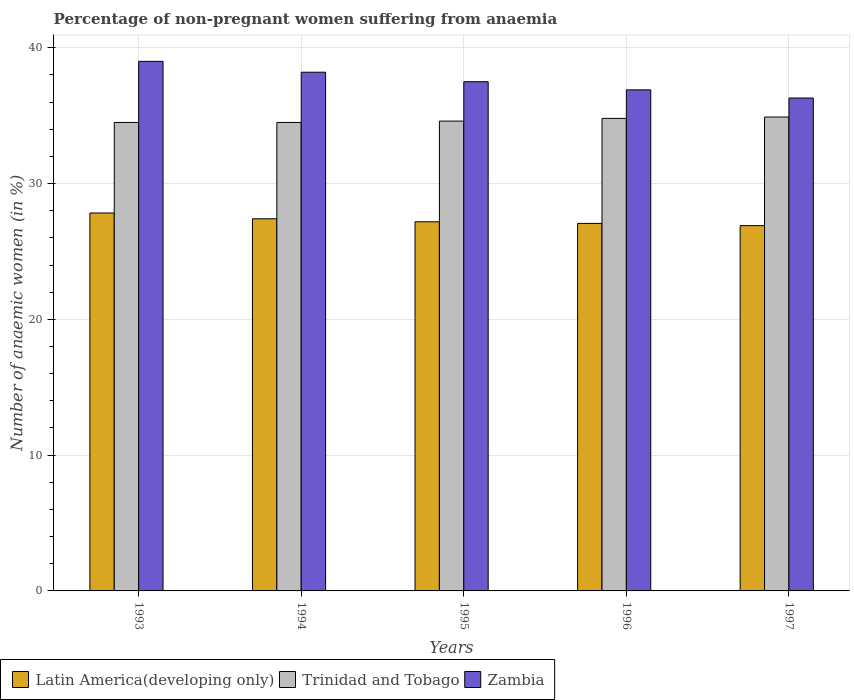How many groups of bars are there?
Provide a short and direct response. 5. Are the number of bars on each tick of the X-axis equal?
Offer a terse response. Yes. How many bars are there on the 3rd tick from the left?
Give a very brief answer. 3. How many bars are there on the 1st tick from the right?
Give a very brief answer. 3. What is the label of the 1st group of bars from the left?
Your answer should be very brief. 1993. In how many cases, is the number of bars for a given year not equal to the number of legend labels?
Your response must be concise. 0. What is the percentage of non-pregnant women suffering from anaemia in Trinidad and Tobago in 1995?
Your answer should be compact. 34.6. Across all years, what is the maximum percentage of non-pregnant women suffering from anaemia in Trinidad and Tobago?
Keep it short and to the point. 34.9. Across all years, what is the minimum percentage of non-pregnant women suffering from anaemia in Trinidad and Tobago?
Offer a terse response. 34.5. In which year was the percentage of non-pregnant women suffering from anaemia in Latin America(developing only) maximum?
Your answer should be very brief. 1993. In which year was the percentage of non-pregnant women suffering from anaemia in Zambia minimum?
Give a very brief answer. 1997. What is the total percentage of non-pregnant women suffering from anaemia in Latin America(developing only) in the graph?
Give a very brief answer. 136.39. What is the difference between the percentage of non-pregnant women suffering from anaemia in Trinidad and Tobago in 1995 and that in 1997?
Keep it short and to the point. -0.3. What is the difference between the percentage of non-pregnant women suffering from anaemia in Latin America(developing only) in 1993 and the percentage of non-pregnant women suffering from anaemia in Trinidad and Tobago in 1996?
Your answer should be very brief. -6.97. What is the average percentage of non-pregnant women suffering from anaemia in Trinidad and Tobago per year?
Provide a succinct answer. 34.66. In the year 1994, what is the difference between the percentage of non-pregnant women suffering from anaemia in Trinidad and Tobago and percentage of non-pregnant women suffering from anaemia in Zambia?
Give a very brief answer. -3.7. In how many years, is the percentage of non-pregnant women suffering from anaemia in Trinidad and Tobago greater than 18 %?
Keep it short and to the point. 5. What is the ratio of the percentage of non-pregnant women suffering from anaemia in Zambia in 1993 to that in 1994?
Make the answer very short. 1.02. Is the percentage of non-pregnant women suffering from anaemia in Zambia in 1994 less than that in 1997?
Make the answer very short. No. Is the difference between the percentage of non-pregnant women suffering from anaemia in Trinidad and Tobago in 1996 and 1997 greater than the difference between the percentage of non-pregnant women suffering from anaemia in Zambia in 1996 and 1997?
Provide a succinct answer. No. What is the difference between the highest and the second highest percentage of non-pregnant women suffering from anaemia in Trinidad and Tobago?
Offer a terse response. 0.1. What is the difference between the highest and the lowest percentage of non-pregnant women suffering from anaemia in Trinidad and Tobago?
Make the answer very short. 0.4. Is the sum of the percentage of non-pregnant women suffering from anaemia in Zambia in 1994 and 1996 greater than the maximum percentage of non-pregnant women suffering from anaemia in Trinidad and Tobago across all years?
Your response must be concise. Yes. What does the 3rd bar from the left in 1997 represents?
Offer a terse response. Zambia. What does the 1st bar from the right in 1993 represents?
Keep it short and to the point. Zambia. How many bars are there?
Provide a short and direct response. 15. How many years are there in the graph?
Your answer should be very brief. 5. Does the graph contain grids?
Make the answer very short. Yes. Where does the legend appear in the graph?
Offer a terse response. Bottom left. How many legend labels are there?
Keep it short and to the point. 3. What is the title of the graph?
Offer a very short reply. Percentage of non-pregnant women suffering from anaemia. Does "Burundi" appear as one of the legend labels in the graph?
Give a very brief answer. No. What is the label or title of the Y-axis?
Make the answer very short. Number of anaemic women (in %). What is the Number of anaemic women (in %) of Latin America(developing only) in 1993?
Keep it short and to the point. 27.83. What is the Number of anaemic women (in %) of Trinidad and Tobago in 1993?
Your answer should be very brief. 34.5. What is the Number of anaemic women (in %) of Latin America(developing only) in 1994?
Offer a very short reply. 27.41. What is the Number of anaemic women (in %) of Trinidad and Tobago in 1994?
Offer a very short reply. 34.5. What is the Number of anaemic women (in %) in Zambia in 1994?
Offer a terse response. 38.2. What is the Number of anaemic women (in %) in Latin America(developing only) in 1995?
Your answer should be very brief. 27.19. What is the Number of anaemic women (in %) of Trinidad and Tobago in 1995?
Offer a terse response. 34.6. What is the Number of anaemic women (in %) of Zambia in 1995?
Your answer should be compact. 37.5. What is the Number of anaemic women (in %) in Latin America(developing only) in 1996?
Provide a short and direct response. 27.07. What is the Number of anaemic women (in %) in Trinidad and Tobago in 1996?
Your response must be concise. 34.8. What is the Number of anaemic women (in %) in Zambia in 1996?
Ensure brevity in your answer.  36.9. What is the Number of anaemic women (in %) of Latin America(developing only) in 1997?
Keep it short and to the point. 26.9. What is the Number of anaemic women (in %) in Trinidad and Tobago in 1997?
Offer a terse response. 34.9. What is the Number of anaemic women (in %) in Zambia in 1997?
Your response must be concise. 36.3. Across all years, what is the maximum Number of anaemic women (in %) in Latin America(developing only)?
Your answer should be very brief. 27.83. Across all years, what is the maximum Number of anaemic women (in %) of Trinidad and Tobago?
Your answer should be very brief. 34.9. Across all years, what is the minimum Number of anaemic women (in %) in Latin America(developing only)?
Provide a short and direct response. 26.9. Across all years, what is the minimum Number of anaemic women (in %) of Trinidad and Tobago?
Provide a succinct answer. 34.5. Across all years, what is the minimum Number of anaemic women (in %) in Zambia?
Offer a very short reply. 36.3. What is the total Number of anaemic women (in %) of Latin America(developing only) in the graph?
Offer a very short reply. 136.39. What is the total Number of anaemic women (in %) of Trinidad and Tobago in the graph?
Offer a terse response. 173.3. What is the total Number of anaemic women (in %) in Zambia in the graph?
Give a very brief answer. 187.9. What is the difference between the Number of anaemic women (in %) of Latin America(developing only) in 1993 and that in 1994?
Provide a succinct answer. 0.43. What is the difference between the Number of anaemic women (in %) in Latin America(developing only) in 1993 and that in 1995?
Keep it short and to the point. 0.65. What is the difference between the Number of anaemic women (in %) of Trinidad and Tobago in 1993 and that in 1995?
Provide a short and direct response. -0.1. What is the difference between the Number of anaemic women (in %) in Latin America(developing only) in 1993 and that in 1996?
Offer a very short reply. 0.77. What is the difference between the Number of anaemic women (in %) of Trinidad and Tobago in 1993 and that in 1996?
Provide a succinct answer. -0.3. What is the difference between the Number of anaemic women (in %) of Zambia in 1993 and that in 1996?
Your answer should be very brief. 2.1. What is the difference between the Number of anaemic women (in %) of Latin America(developing only) in 1993 and that in 1997?
Provide a short and direct response. 0.93. What is the difference between the Number of anaemic women (in %) of Latin America(developing only) in 1994 and that in 1995?
Offer a very short reply. 0.22. What is the difference between the Number of anaemic women (in %) in Latin America(developing only) in 1994 and that in 1996?
Keep it short and to the point. 0.34. What is the difference between the Number of anaemic women (in %) of Latin America(developing only) in 1994 and that in 1997?
Ensure brevity in your answer.  0.51. What is the difference between the Number of anaemic women (in %) of Trinidad and Tobago in 1994 and that in 1997?
Offer a very short reply. -0.4. What is the difference between the Number of anaemic women (in %) in Zambia in 1994 and that in 1997?
Your answer should be very brief. 1.9. What is the difference between the Number of anaemic women (in %) of Latin America(developing only) in 1995 and that in 1996?
Keep it short and to the point. 0.12. What is the difference between the Number of anaemic women (in %) in Zambia in 1995 and that in 1996?
Provide a short and direct response. 0.6. What is the difference between the Number of anaemic women (in %) of Latin America(developing only) in 1995 and that in 1997?
Ensure brevity in your answer.  0.28. What is the difference between the Number of anaemic women (in %) in Trinidad and Tobago in 1995 and that in 1997?
Your answer should be very brief. -0.3. What is the difference between the Number of anaemic women (in %) in Latin America(developing only) in 1996 and that in 1997?
Offer a terse response. 0.16. What is the difference between the Number of anaemic women (in %) in Latin America(developing only) in 1993 and the Number of anaemic women (in %) in Trinidad and Tobago in 1994?
Offer a very short reply. -6.67. What is the difference between the Number of anaemic women (in %) of Latin America(developing only) in 1993 and the Number of anaemic women (in %) of Zambia in 1994?
Provide a short and direct response. -10.37. What is the difference between the Number of anaemic women (in %) of Latin America(developing only) in 1993 and the Number of anaemic women (in %) of Trinidad and Tobago in 1995?
Your response must be concise. -6.77. What is the difference between the Number of anaemic women (in %) in Latin America(developing only) in 1993 and the Number of anaemic women (in %) in Zambia in 1995?
Provide a short and direct response. -9.67. What is the difference between the Number of anaemic women (in %) in Latin America(developing only) in 1993 and the Number of anaemic women (in %) in Trinidad and Tobago in 1996?
Your answer should be very brief. -6.97. What is the difference between the Number of anaemic women (in %) in Latin America(developing only) in 1993 and the Number of anaemic women (in %) in Zambia in 1996?
Your answer should be very brief. -9.07. What is the difference between the Number of anaemic women (in %) in Latin America(developing only) in 1993 and the Number of anaemic women (in %) in Trinidad and Tobago in 1997?
Keep it short and to the point. -7.07. What is the difference between the Number of anaemic women (in %) of Latin America(developing only) in 1993 and the Number of anaemic women (in %) of Zambia in 1997?
Your answer should be very brief. -8.47. What is the difference between the Number of anaemic women (in %) in Latin America(developing only) in 1994 and the Number of anaemic women (in %) in Trinidad and Tobago in 1995?
Offer a terse response. -7.19. What is the difference between the Number of anaemic women (in %) of Latin America(developing only) in 1994 and the Number of anaemic women (in %) of Zambia in 1995?
Ensure brevity in your answer.  -10.09. What is the difference between the Number of anaemic women (in %) of Latin America(developing only) in 1994 and the Number of anaemic women (in %) of Trinidad and Tobago in 1996?
Ensure brevity in your answer.  -7.39. What is the difference between the Number of anaemic women (in %) of Latin America(developing only) in 1994 and the Number of anaemic women (in %) of Zambia in 1996?
Offer a very short reply. -9.49. What is the difference between the Number of anaemic women (in %) in Trinidad and Tobago in 1994 and the Number of anaemic women (in %) in Zambia in 1996?
Offer a very short reply. -2.4. What is the difference between the Number of anaemic women (in %) in Latin America(developing only) in 1994 and the Number of anaemic women (in %) in Trinidad and Tobago in 1997?
Provide a succinct answer. -7.49. What is the difference between the Number of anaemic women (in %) of Latin America(developing only) in 1994 and the Number of anaemic women (in %) of Zambia in 1997?
Provide a short and direct response. -8.89. What is the difference between the Number of anaemic women (in %) of Trinidad and Tobago in 1994 and the Number of anaemic women (in %) of Zambia in 1997?
Your response must be concise. -1.8. What is the difference between the Number of anaemic women (in %) of Latin America(developing only) in 1995 and the Number of anaemic women (in %) of Trinidad and Tobago in 1996?
Your answer should be compact. -7.61. What is the difference between the Number of anaemic women (in %) of Latin America(developing only) in 1995 and the Number of anaemic women (in %) of Zambia in 1996?
Offer a very short reply. -9.71. What is the difference between the Number of anaemic women (in %) of Latin America(developing only) in 1995 and the Number of anaemic women (in %) of Trinidad and Tobago in 1997?
Your answer should be compact. -7.71. What is the difference between the Number of anaemic women (in %) of Latin America(developing only) in 1995 and the Number of anaemic women (in %) of Zambia in 1997?
Your answer should be compact. -9.11. What is the difference between the Number of anaemic women (in %) of Latin America(developing only) in 1996 and the Number of anaemic women (in %) of Trinidad and Tobago in 1997?
Make the answer very short. -7.83. What is the difference between the Number of anaemic women (in %) in Latin America(developing only) in 1996 and the Number of anaemic women (in %) in Zambia in 1997?
Offer a very short reply. -9.23. What is the difference between the Number of anaemic women (in %) of Trinidad and Tobago in 1996 and the Number of anaemic women (in %) of Zambia in 1997?
Ensure brevity in your answer.  -1.5. What is the average Number of anaemic women (in %) of Latin America(developing only) per year?
Provide a succinct answer. 27.28. What is the average Number of anaemic women (in %) in Trinidad and Tobago per year?
Provide a succinct answer. 34.66. What is the average Number of anaemic women (in %) in Zambia per year?
Your answer should be compact. 37.58. In the year 1993, what is the difference between the Number of anaemic women (in %) of Latin America(developing only) and Number of anaemic women (in %) of Trinidad and Tobago?
Your answer should be very brief. -6.67. In the year 1993, what is the difference between the Number of anaemic women (in %) in Latin America(developing only) and Number of anaemic women (in %) in Zambia?
Give a very brief answer. -11.17. In the year 1994, what is the difference between the Number of anaemic women (in %) of Latin America(developing only) and Number of anaemic women (in %) of Trinidad and Tobago?
Your answer should be compact. -7.09. In the year 1994, what is the difference between the Number of anaemic women (in %) of Latin America(developing only) and Number of anaemic women (in %) of Zambia?
Offer a very short reply. -10.79. In the year 1994, what is the difference between the Number of anaemic women (in %) in Trinidad and Tobago and Number of anaemic women (in %) in Zambia?
Provide a succinct answer. -3.7. In the year 1995, what is the difference between the Number of anaemic women (in %) in Latin America(developing only) and Number of anaemic women (in %) in Trinidad and Tobago?
Your answer should be compact. -7.41. In the year 1995, what is the difference between the Number of anaemic women (in %) in Latin America(developing only) and Number of anaemic women (in %) in Zambia?
Give a very brief answer. -10.31. In the year 1995, what is the difference between the Number of anaemic women (in %) of Trinidad and Tobago and Number of anaemic women (in %) of Zambia?
Your answer should be compact. -2.9. In the year 1996, what is the difference between the Number of anaemic women (in %) of Latin America(developing only) and Number of anaemic women (in %) of Trinidad and Tobago?
Ensure brevity in your answer.  -7.73. In the year 1996, what is the difference between the Number of anaemic women (in %) of Latin America(developing only) and Number of anaemic women (in %) of Zambia?
Provide a short and direct response. -9.83. In the year 1997, what is the difference between the Number of anaemic women (in %) of Latin America(developing only) and Number of anaemic women (in %) of Trinidad and Tobago?
Provide a succinct answer. -8. In the year 1997, what is the difference between the Number of anaemic women (in %) in Latin America(developing only) and Number of anaemic women (in %) in Zambia?
Give a very brief answer. -9.4. What is the ratio of the Number of anaemic women (in %) of Latin America(developing only) in 1993 to that in 1994?
Your response must be concise. 1.02. What is the ratio of the Number of anaemic women (in %) in Zambia in 1993 to that in 1994?
Offer a very short reply. 1.02. What is the ratio of the Number of anaemic women (in %) in Latin America(developing only) in 1993 to that in 1995?
Your answer should be very brief. 1.02. What is the ratio of the Number of anaemic women (in %) of Latin America(developing only) in 1993 to that in 1996?
Give a very brief answer. 1.03. What is the ratio of the Number of anaemic women (in %) of Zambia in 1993 to that in 1996?
Give a very brief answer. 1.06. What is the ratio of the Number of anaemic women (in %) of Latin America(developing only) in 1993 to that in 1997?
Keep it short and to the point. 1.03. What is the ratio of the Number of anaemic women (in %) of Zambia in 1993 to that in 1997?
Ensure brevity in your answer.  1.07. What is the ratio of the Number of anaemic women (in %) of Trinidad and Tobago in 1994 to that in 1995?
Ensure brevity in your answer.  1. What is the ratio of the Number of anaemic women (in %) of Zambia in 1994 to that in 1995?
Provide a succinct answer. 1.02. What is the ratio of the Number of anaemic women (in %) of Latin America(developing only) in 1994 to that in 1996?
Give a very brief answer. 1.01. What is the ratio of the Number of anaemic women (in %) in Zambia in 1994 to that in 1996?
Offer a very short reply. 1.04. What is the ratio of the Number of anaemic women (in %) in Latin America(developing only) in 1994 to that in 1997?
Offer a very short reply. 1.02. What is the ratio of the Number of anaemic women (in %) of Zambia in 1994 to that in 1997?
Ensure brevity in your answer.  1.05. What is the ratio of the Number of anaemic women (in %) of Zambia in 1995 to that in 1996?
Keep it short and to the point. 1.02. What is the ratio of the Number of anaemic women (in %) of Latin America(developing only) in 1995 to that in 1997?
Provide a short and direct response. 1.01. What is the ratio of the Number of anaemic women (in %) in Trinidad and Tobago in 1995 to that in 1997?
Offer a terse response. 0.99. What is the ratio of the Number of anaemic women (in %) of Zambia in 1995 to that in 1997?
Offer a terse response. 1.03. What is the ratio of the Number of anaemic women (in %) in Latin America(developing only) in 1996 to that in 1997?
Ensure brevity in your answer.  1.01. What is the ratio of the Number of anaemic women (in %) in Trinidad and Tobago in 1996 to that in 1997?
Your answer should be compact. 1. What is the ratio of the Number of anaemic women (in %) in Zambia in 1996 to that in 1997?
Offer a very short reply. 1.02. What is the difference between the highest and the second highest Number of anaemic women (in %) in Latin America(developing only)?
Keep it short and to the point. 0.43. What is the difference between the highest and the second highest Number of anaemic women (in %) in Trinidad and Tobago?
Provide a short and direct response. 0.1. What is the difference between the highest and the lowest Number of anaemic women (in %) in Latin America(developing only)?
Keep it short and to the point. 0.93. What is the difference between the highest and the lowest Number of anaemic women (in %) of Zambia?
Your response must be concise. 2.7. 